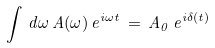<formula> <loc_0><loc_0><loc_500><loc_500>\int \, d \omega \, A ( \omega ) \, e ^ { i \omega t } \, = \, A _ { 0 } \, e ^ { i \delta ( t ) }</formula> 